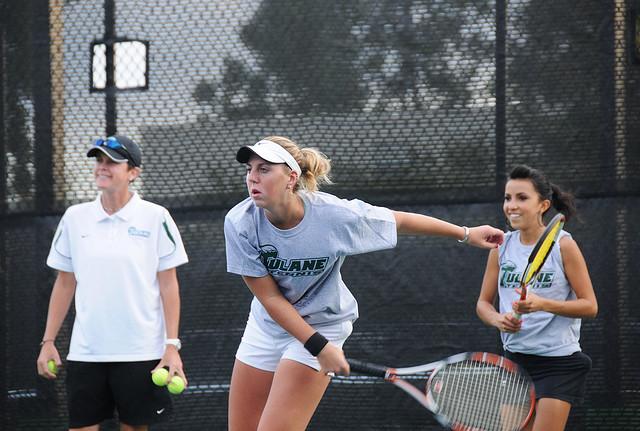Do you think she takes the game seriously?
Be succinct. Yes. How many people are wearing a cap?
Answer briefly. 2. What is the knot on her hip?
Concise answer only. Ball. Is this a professional tennis lesson?
Write a very short answer. Yes. What kind of skirt is the girl on the right wearing?
Keep it brief. Tennis. What is the black fence made of?
Write a very short answer. Metal. What color balls are they playing with?
Short answer required. Green. How many balls are there?
Concise answer only. 3. What are they looking at?
Give a very brief answer. Ball. What is the woman wearing?
Give a very brief answer. Shorts. Who is taller?
Be succinct. Blonde. 